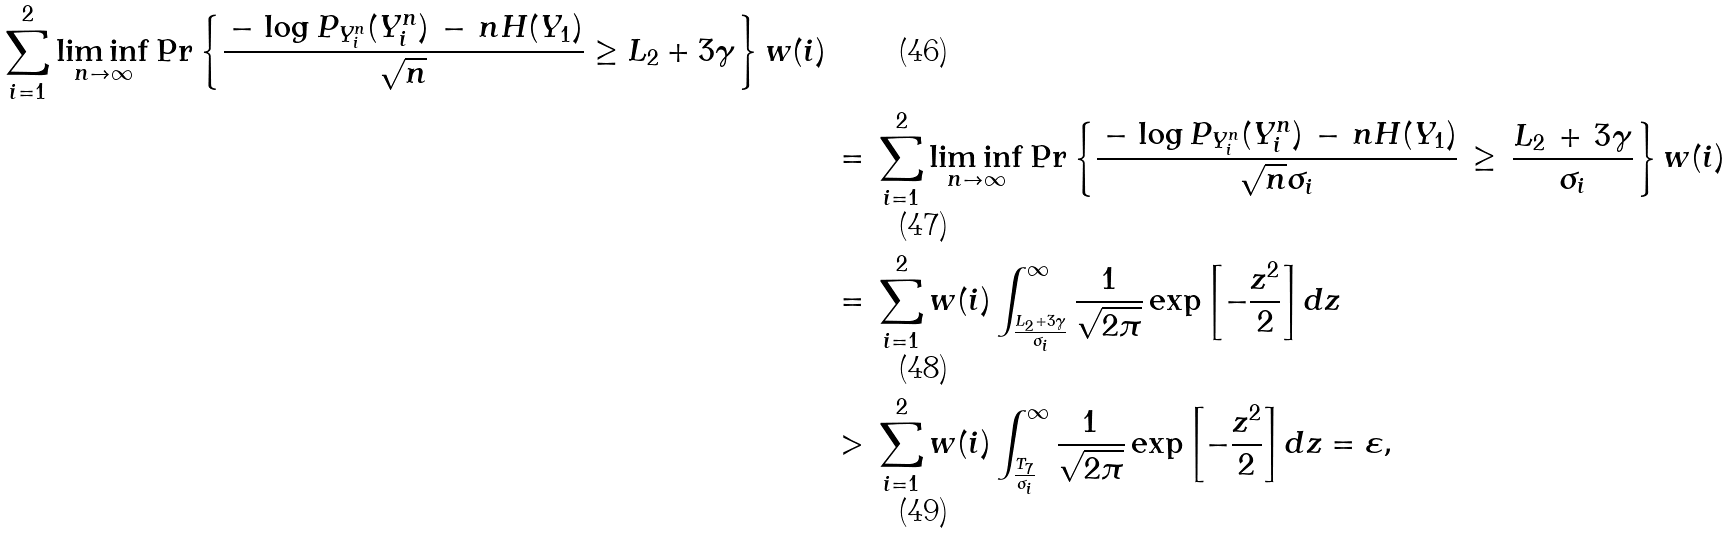<formula> <loc_0><loc_0><loc_500><loc_500>{ \sum _ { i = 1 } ^ { 2 } \liminf _ { n \to \infty } \Pr \left \{ \frac { \, - \, \log P _ { Y _ { i } ^ { n } } ( Y _ { i } ^ { n } ) \, - \, n H ( Y _ { 1 } ) } { \sqrt { n } } \geq L _ { 2 } + 3 \gamma \right \} w ( i ) } \\ & \, = \, \sum _ { i = 1 } ^ { 2 } \liminf _ { n \to \infty } \Pr \left \{ \frac { \, - \, \log P _ { Y _ { i } ^ { n } } ( Y _ { i } ^ { n } ) \, - \, n H ( Y _ { 1 } ) } { \sqrt { n } \sigma _ { i } } \, \geq \, \frac { L _ { 2 } \, + \, 3 \gamma } { \sigma _ { i } } \right \} w ( i ) \\ & \, = \, \sum _ { i = 1 } ^ { 2 } w ( i ) \int ^ { \infty } _ { \frac { L _ { 2 } + 3 \gamma } { \sigma _ { i } } } \frac { 1 } { \sqrt { 2 \pi } } \exp \left [ - \frac { z ^ { 2 } } { 2 } \right ] d z \\ & \, > \, \sum _ { i = 1 } ^ { 2 } w ( i ) \int ^ { \infty } _ { \frac { T _ { 7 } } { \sigma _ { i } } } \frac { 1 } { \sqrt { 2 \pi } } \exp \left [ - \frac { z ^ { 2 } } { 2 } \right ] d z = \varepsilon ,</formula> 